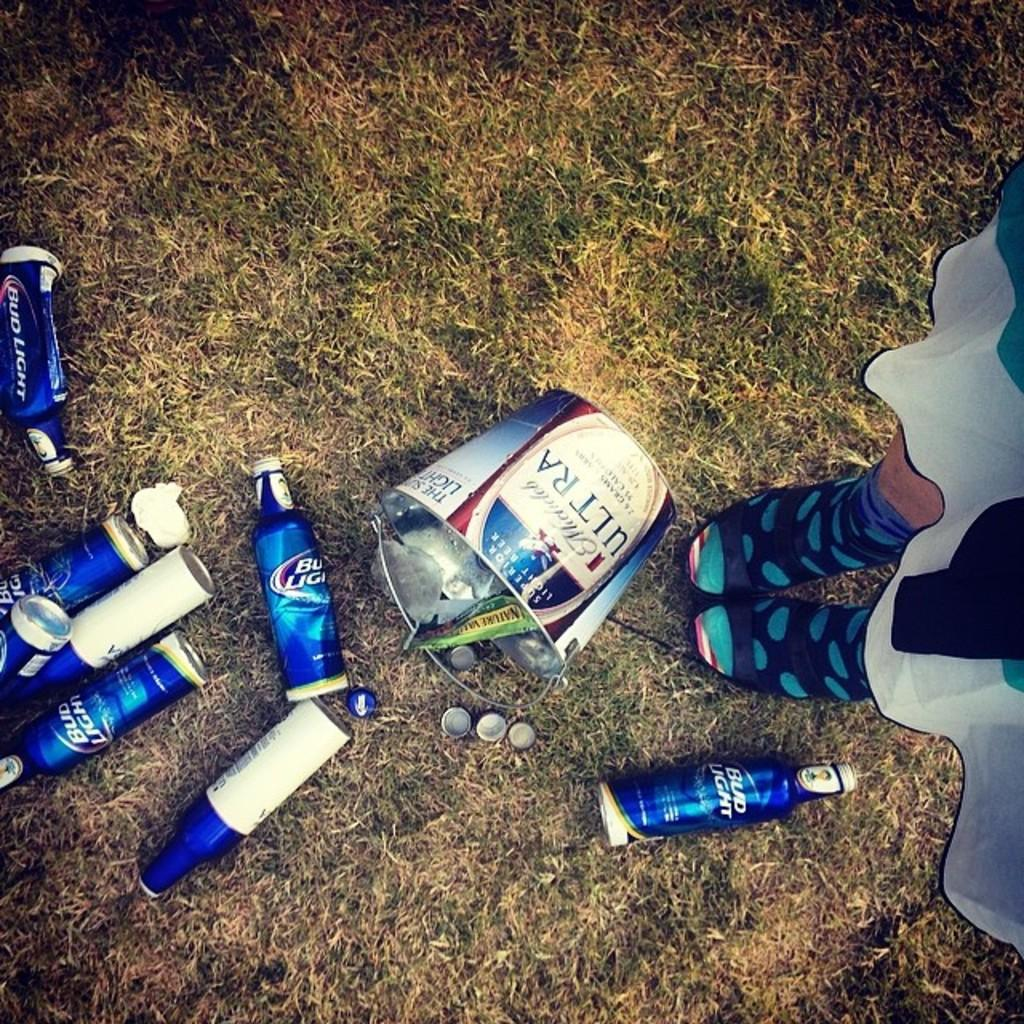<image>
Provide a brief description of the given image. A spilled bucket of Bud Light beers lies on the ground. 